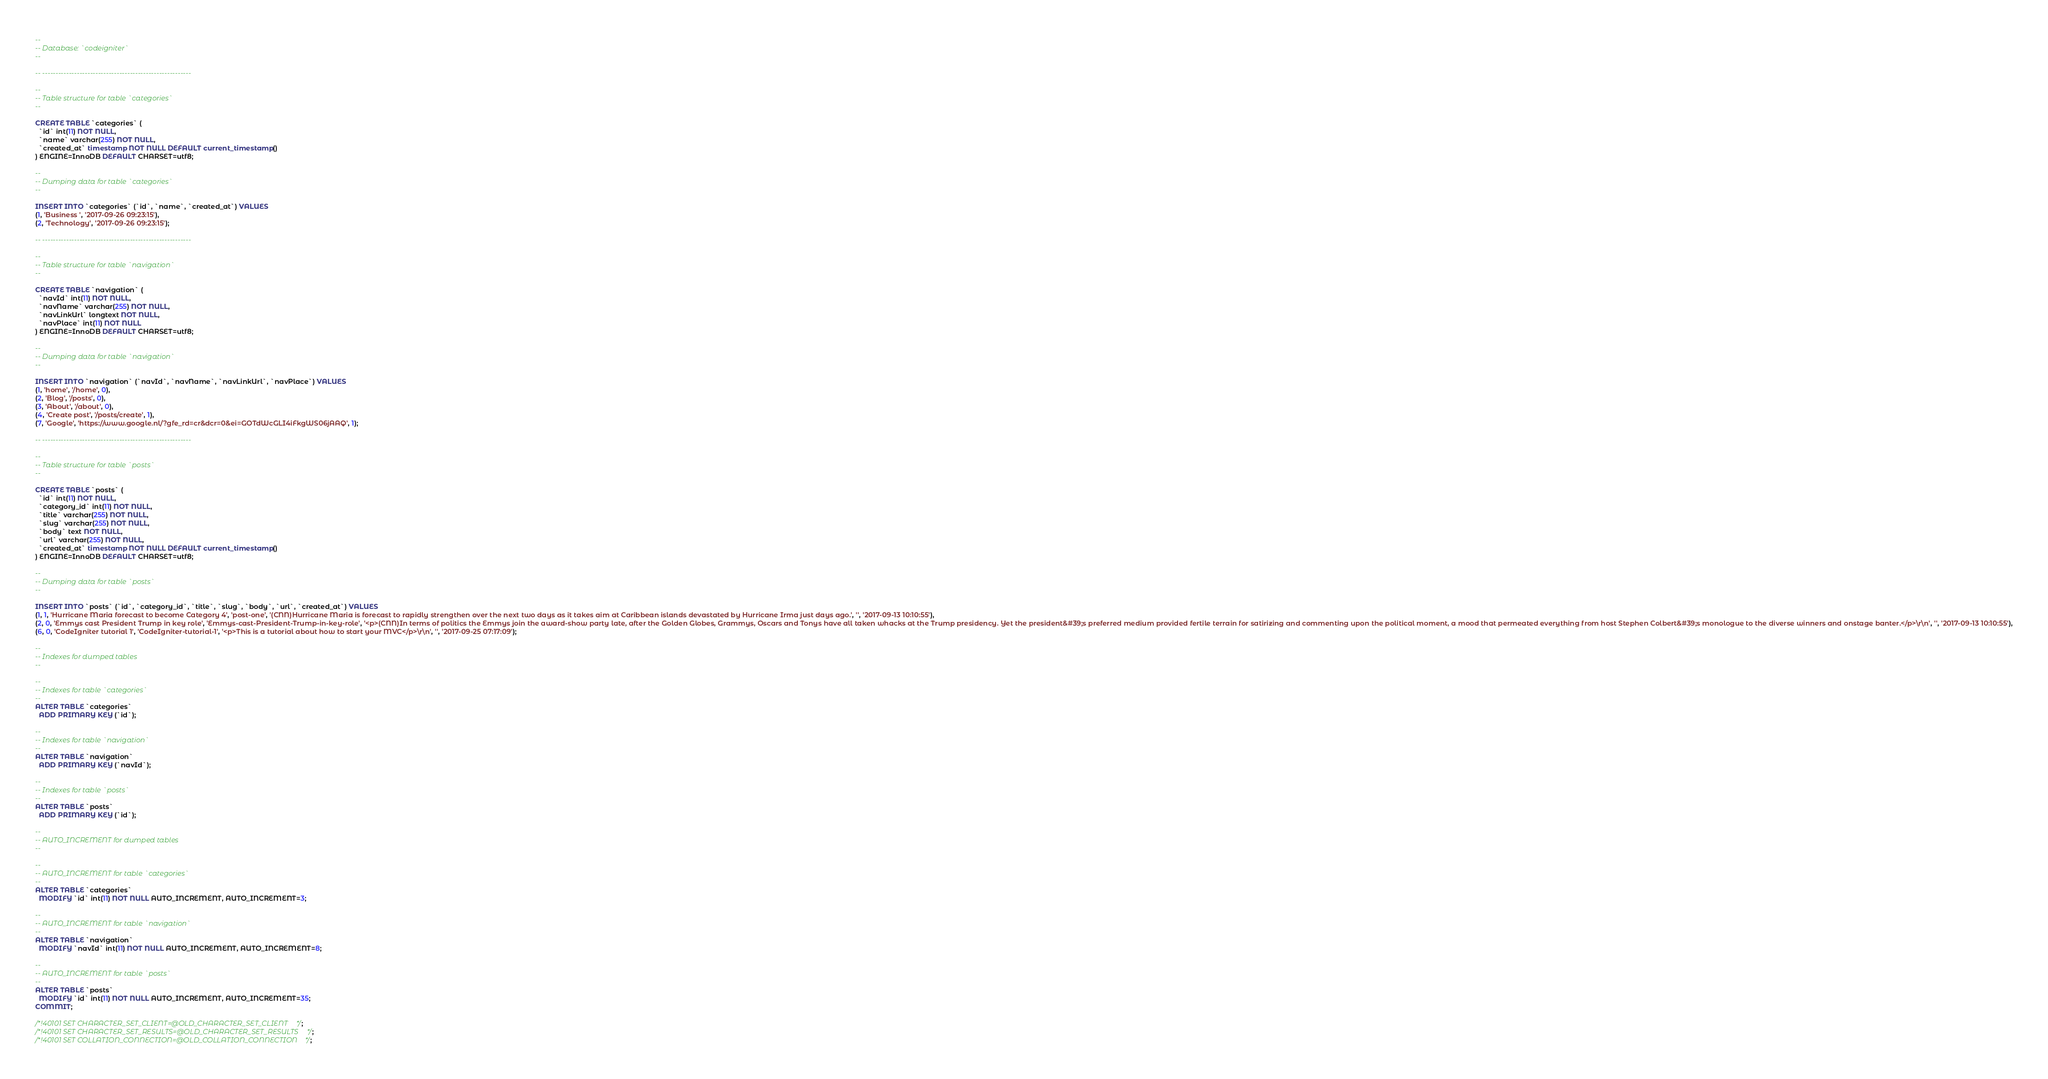<code> <loc_0><loc_0><loc_500><loc_500><_SQL_>
--
-- Database: `codeigniter`
--

-- --------------------------------------------------------

--
-- Table structure for table `categories`
--

CREATE TABLE `categories` (
  `id` int(11) NOT NULL,
  `name` varchar(255) NOT NULL,
  `created_at` timestamp NOT NULL DEFAULT current_timestamp()
) ENGINE=InnoDB DEFAULT CHARSET=utf8;

--
-- Dumping data for table `categories`
--

INSERT INTO `categories` (`id`, `name`, `created_at`) VALUES
(1, 'Business ', '2017-09-26 09:23:15'),
(2, 'Technology', '2017-09-26 09:23:15');

-- --------------------------------------------------------

--
-- Table structure for table `navigation`
--

CREATE TABLE `navigation` (
  `navId` int(11) NOT NULL,
  `navName` varchar(255) NOT NULL,
  `navLinkUrl` longtext NOT NULL,
  `navPlace` int(11) NOT NULL
) ENGINE=InnoDB DEFAULT CHARSET=utf8;

--
-- Dumping data for table `navigation`
--

INSERT INTO `navigation` (`navId`, `navName`, `navLinkUrl`, `navPlace`) VALUES
(1, 'home', '/home', 0),
(2, 'Blog', '/posts', 0),
(3, 'About', '/about', 0),
(4, 'Create post', '/posts/create', 1),
(7, 'Google', 'https://www.google.nl/?gfe_rd=cr&dcr=0&ei=GOTdWcGLI4iFkgWS06jAAQ', 1);

-- --------------------------------------------------------

--
-- Table structure for table `posts`
--

CREATE TABLE `posts` (
  `id` int(11) NOT NULL,
  `category_id` int(11) NOT NULL,
  `title` varchar(255) NOT NULL,
  `slug` varchar(255) NOT NULL,
  `body` text NOT NULL,
  `url` varchar(255) NOT NULL,
  `created_at` timestamp NOT NULL DEFAULT current_timestamp()
) ENGINE=InnoDB DEFAULT CHARSET=utf8;

--
-- Dumping data for table `posts`
--

INSERT INTO `posts` (`id`, `category_id`, `title`, `slug`, `body`, `url`, `created_at`) VALUES
(1, 1, 'Hurricane Maria forecast to become Category 4', 'post-one', '(CNN)Hurricane Maria is forecast to rapidly strengthen over the next two days as it takes aim at Caribbean islands devastated by Hurricane Irma just days ago.', '', '2017-09-13 10:10:55'),
(2, 0, 'Emmys cast President Trump in key role', 'Emmys-cast-President-Trump-in-key-role', '<p>(CNN)In terms of politics the Emmys join the award-show party late, after the Golden Globes, Grammys, Oscars and Tonys have all taken whacks at the Trump presidency. Yet the president&#39;s preferred medium provided fertile terrain for satirizing and commenting upon the political moment, a mood that permeated everything from host Stephen Colbert&#39;s monologue to the diverse winners and onstage banter.</p>\r\n', '', '2017-09-13 10:10:55'),
(6, 0, 'CodeIgniter tutorial 1', 'CodeIgniter-tutorial-1', '<p>This is a tutorial about how to start your MVC</p>\r\n', '', '2017-09-25 07:17:09');

--
-- Indexes for dumped tables
--

--
-- Indexes for table `categories`
--
ALTER TABLE `categories`
  ADD PRIMARY KEY (`id`);

--
-- Indexes for table `navigation`
--
ALTER TABLE `navigation`
  ADD PRIMARY KEY (`navId`);

--
-- Indexes for table `posts`
--
ALTER TABLE `posts`
  ADD PRIMARY KEY (`id`);

--
-- AUTO_INCREMENT for dumped tables
--

--
-- AUTO_INCREMENT for table `categories`
--
ALTER TABLE `categories`
  MODIFY `id` int(11) NOT NULL AUTO_INCREMENT, AUTO_INCREMENT=3;

--
-- AUTO_INCREMENT for table `navigation`
--
ALTER TABLE `navigation`
  MODIFY `navId` int(11) NOT NULL AUTO_INCREMENT, AUTO_INCREMENT=8;

--
-- AUTO_INCREMENT for table `posts`
--
ALTER TABLE `posts`
  MODIFY `id` int(11) NOT NULL AUTO_INCREMENT, AUTO_INCREMENT=35;
COMMIT;

/*!40101 SET CHARACTER_SET_CLIENT=@OLD_CHARACTER_SET_CLIENT */;
/*!40101 SET CHARACTER_SET_RESULTS=@OLD_CHARACTER_SET_RESULTS */;
/*!40101 SET COLLATION_CONNECTION=@OLD_COLLATION_CONNECTION */;
</code> 